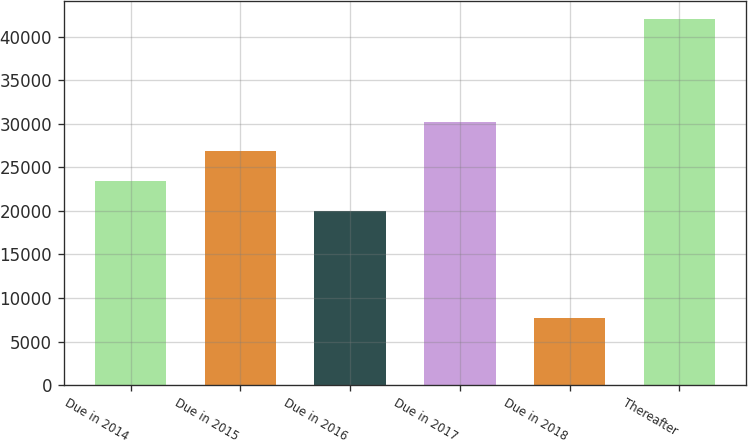Convert chart. <chart><loc_0><loc_0><loc_500><loc_500><bar_chart><fcel>Due in 2014<fcel>Due in 2015<fcel>Due in 2016<fcel>Due in 2017<fcel>Due in 2018<fcel>Thereafter<nl><fcel>23411.7<fcel>26839.4<fcel>19984<fcel>30267.1<fcel>7733<fcel>42010<nl></chart> 